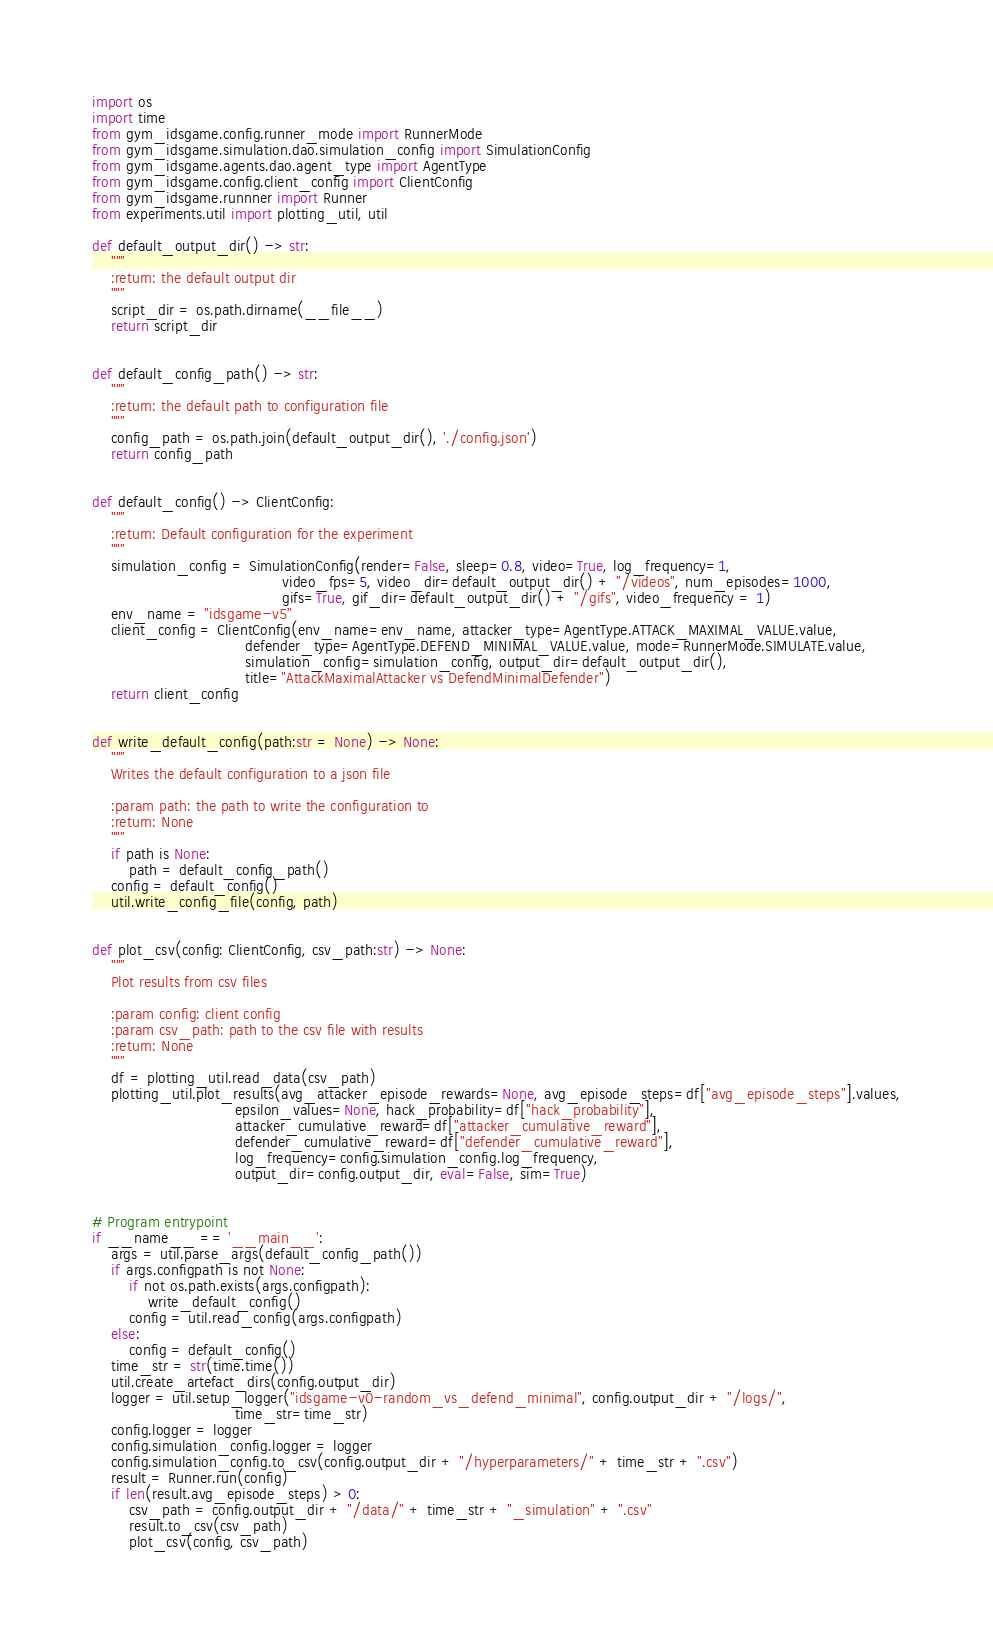Convert code to text. <code><loc_0><loc_0><loc_500><loc_500><_Python_>import os
import time
from gym_idsgame.config.runner_mode import RunnerMode
from gym_idsgame.simulation.dao.simulation_config import SimulationConfig
from gym_idsgame.agents.dao.agent_type import AgentType
from gym_idsgame.config.client_config import ClientConfig
from gym_idsgame.runnner import Runner
from experiments.util import plotting_util, util

def default_output_dir() -> str:
    """
    :return: the default output dir
    """
    script_dir = os.path.dirname(__file__)
    return script_dir


def default_config_path() -> str:
    """
    :return: the default path to configuration file
    """
    config_path = os.path.join(default_output_dir(), './config.json')
    return config_path


def default_config() -> ClientConfig:
    """
    :return: Default configuration for the experiment
    """
    simulation_config = SimulationConfig(render=False, sleep=0.8, video=True, log_frequency=1,
                                         video_fps=5, video_dir=default_output_dir() + "/videos", num_episodes=1000,
                                         gifs=True, gif_dir=default_output_dir() + "/gifs", video_frequency = 1)
    env_name = "idsgame-v5"
    client_config = ClientConfig(env_name=env_name, attacker_type=AgentType.ATTACK_MAXIMAL_VALUE.value,
                                 defender_type=AgentType.DEFEND_MINIMAL_VALUE.value, mode=RunnerMode.SIMULATE.value,
                                 simulation_config=simulation_config, output_dir=default_output_dir(),
                                 title="AttackMaximalAttacker vs DefendMinimalDefender")
    return client_config


def write_default_config(path:str = None) -> None:
    """
    Writes the default configuration to a json file

    :param path: the path to write the configuration to
    :return: None
    """
    if path is None:
        path = default_config_path()
    config = default_config()
    util.write_config_file(config, path)


def plot_csv(config: ClientConfig, csv_path:str) -> None:
    """
    Plot results from csv files

    :param config: client config
    :param csv_path: path to the csv file with results
    :return: None
    """
    df = plotting_util.read_data(csv_path)
    plotting_util.plot_results(avg_attacker_episode_rewards=None, avg_episode_steps=df["avg_episode_steps"].values,
                               epsilon_values=None, hack_probability=df["hack_probability"],
                               attacker_cumulative_reward=df["attacker_cumulative_reward"],
                               defender_cumulative_reward=df["defender_cumulative_reward"],
                               log_frequency=config.simulation_config.log_frequency,
                               output_dir=config.output_dir, eval=False, sim=True)


# Program entrypoint
if __name__ == '__main__':
    args = util.parse_args(default_config_path())
    if args.configpath is not None:
        if not os.path.exists(args.configpath):
            write_default_config()
        config = util.read_config(args.configpath)
    else:
        config = default_config()
    time_str = str(time.time())
    util.create_artefact_dirs(config.output_dir)
    logger = util.setup_logger("idsgame-v0-random_vs_defend_minimal", config.output_dir + "/logs/",
                               time_str=time_str)
    config.logger = logger
    config.simulation_config.logger = logger
    config.simulation_config.to_csv(config.output_dir + "/hyperparameters/" + time_str + ".csv")
    result = Runner.run(config)
    if len(result.avg_episode_steps) > 0:
        csv_path = config.output_dir + "/data/" + time_str + "_simulation" + ".csv"
        result.to_csv(csv_path)
        plot_csv(config, csv_path)



</code> 